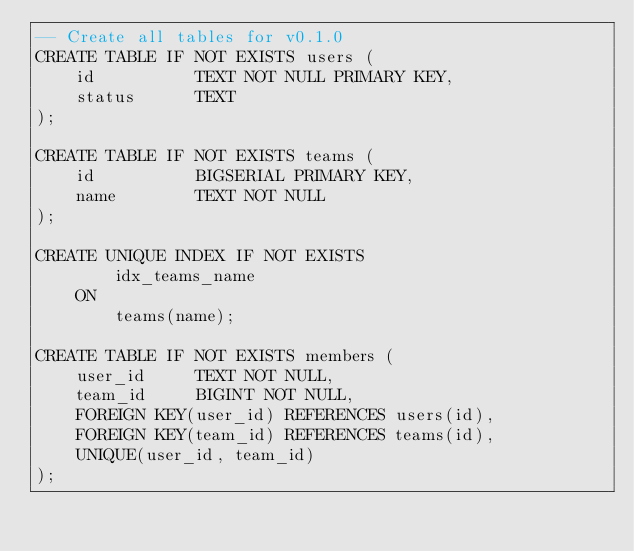Convert code to text. <code><loc_0><loc_0><loc_500><loc_500><_SQL_>-- Create all tables for v0.1.0
CREATE TABLE IF NOT EXISTS users (
    id          TEXT NOT NULL PRIMARY KEY,
    status      TEXT
);

CREATE TABLE IF NOT EXISTS teams (
    id          BIGSERIAL PRIMARY KEY,
    name        TEXT NOT NULL 
);

CREATE UNIQUE INDEX IF NOT EXISTS
        idx_teams_name
    ON
        teams(name);

CREATE TABLE IF NOT EXISTS members (
    user_id     TEXT NOT NULL,
    team_id     BIGINT NOT NULL,
    FOREIGN KEY(user_id) REFERENCES users(id),
    FOREIGN KEY(team_id) REFERENCES teams(id),
    UNIQUE(user_id, team_id)
);
</code> 